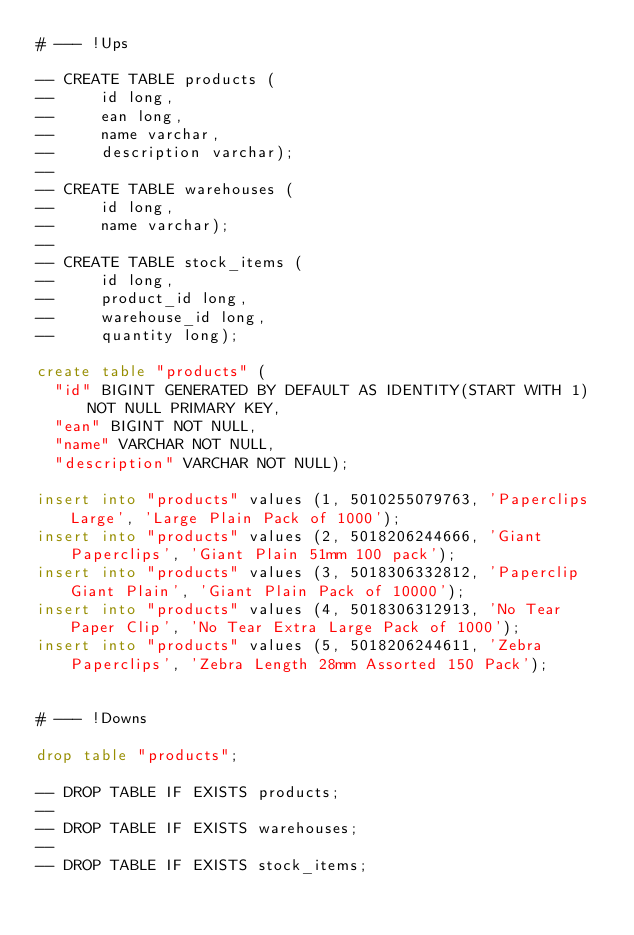<code> <loc_0><loc_0><loc_500><loc_500><_SQL_># --- !Ups

-- CREATE TABLE products (
--     id long,
--     ean long,
--     name varchar,
--     description varchar);
--
-- CREATE TABLE warehouses (
--     id long,
--     name varchar);
--
-- CREATE TABLE stock_items (
--     id long,
--     product_id long,
--     warehouse_id long,
--     quantity long);

create table "products" (
  "id" BIGINT GENERATED BY DEFAULT AS IDENTITY(START WITH 1) NOT NULL PRIMARY KEY,
  "ean" BIGINT NOT NULL,
  "name" VARCHAR NOT NULL,
  "description" VARCHAR NOT NULL);

insert into "products" values (1, 5010255079763, 'Paperclips Large', 'Large Plain Pack of 1000');
insert into "products" values (2, 5018206244666, 'Giant Paperclips', 'Giant Plain 51mm 100 pack');
insert into "products" values (3, 5018306332812, 'Paperclip Giant Plain', 'Giant Plain Pack of 10000');
insert into "products" values (4, 5018306312913, 'No Tear Paper Clip', 'No Tear Extra Large Pack of 1000');
insert into "products" values (5, 5018206244611, 'Zebra Paperclips', 'Zebra Length 28mm Assorted 150 Pack');


# --- !Downs

drop table "products";

-- DROP TABLE IF EXISTS products;
--
-- DROP TABLE IF EXISTS warehouses;
--
-- DROP TABLE IF EXISTS stock_items;
</code> 